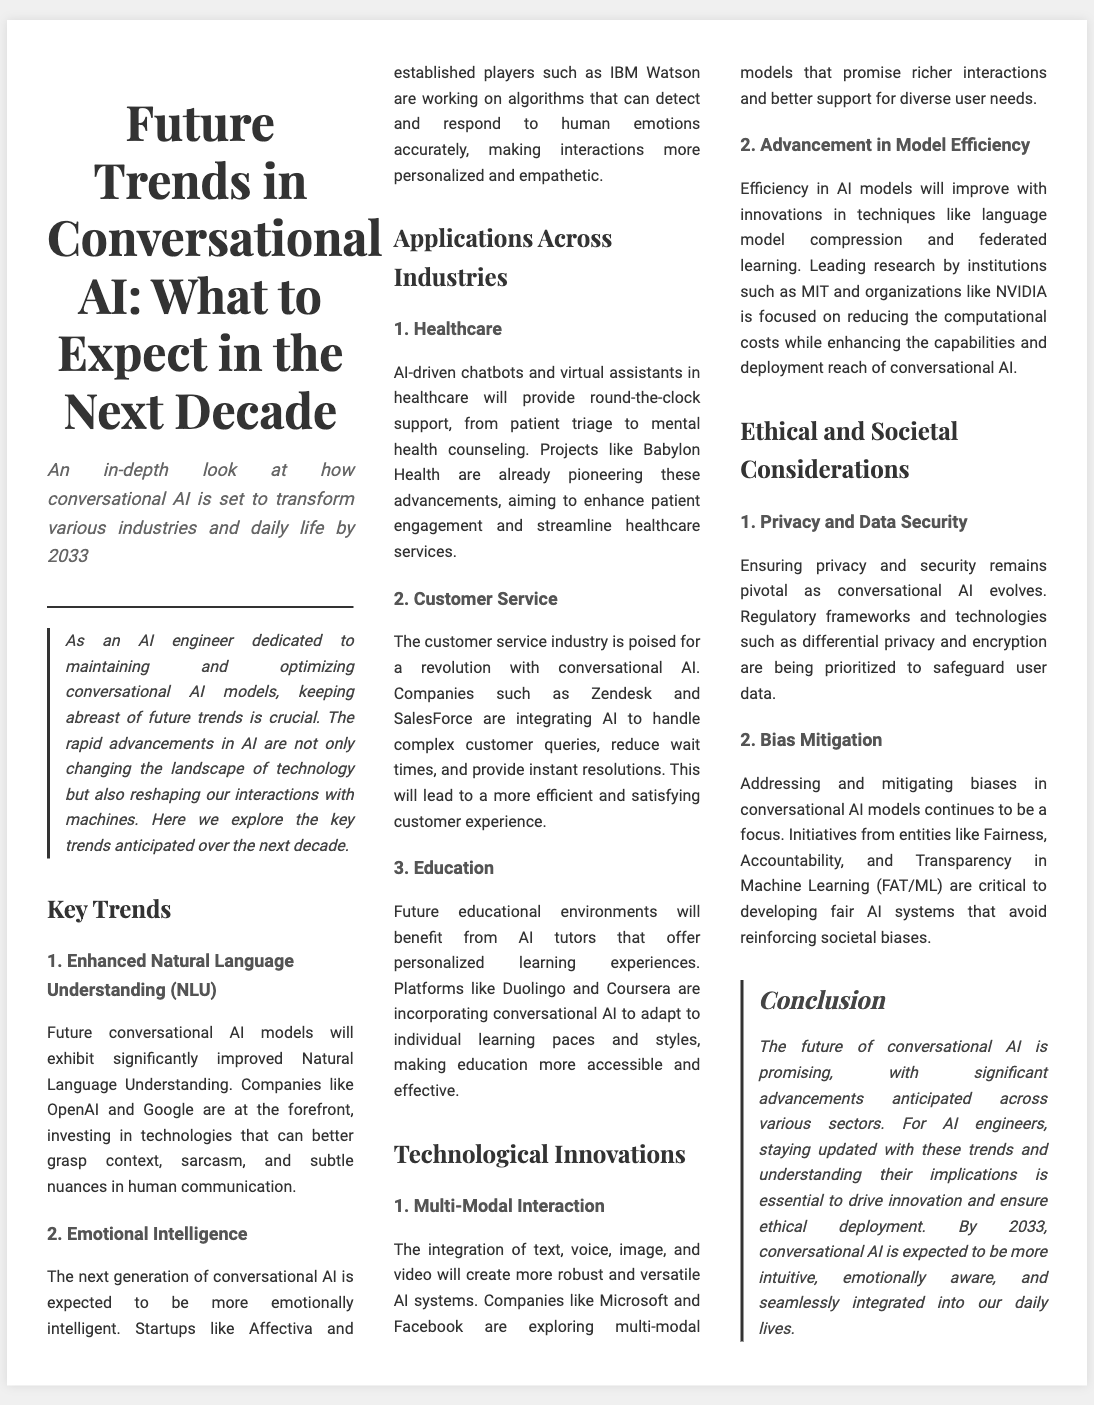What is the title of the document? The title is prominently displayed at the top of the newspaper layout.
Answer: Future Trends in Conversational AI: What to Expect in the Next Decade What year is mentioned for expected advancements? The document discusses expectations for the future specifically regarding the year 2033.
Answer: 2033 Which industry is mentioned first in the applications section? The first industry mentioned in the applications section is indicative of its importance in the context discussed.
Answer: Healthcare Who are the companies mentioned making advancements in Natural Language Understanding? The text names companies at the forefront of investing in NLU technology.
Answer: OpenAI and Google What is one of the key technological innovations highlighted? The document lists advancements in technology as part of the trends.
Answer: Multi-Modal Interaction What ethical consideration is discussed in relation to conversational AI? Ethical and societal issues are important aspects covered by the document.
Answer: Privacy and Data Security What is the focus of the initiatives from Fairness, Accountability, and Transparency in Machine Learning? The document explains these initiatives as part of the efforts to improve AI systems.
Answer: Bias Mitigation Name one company involved in ensuring emotional intelligence in conversational AI. The text identifies companies that are working on emotional intelligence capabilities in AI.
Answer: Affectiva 